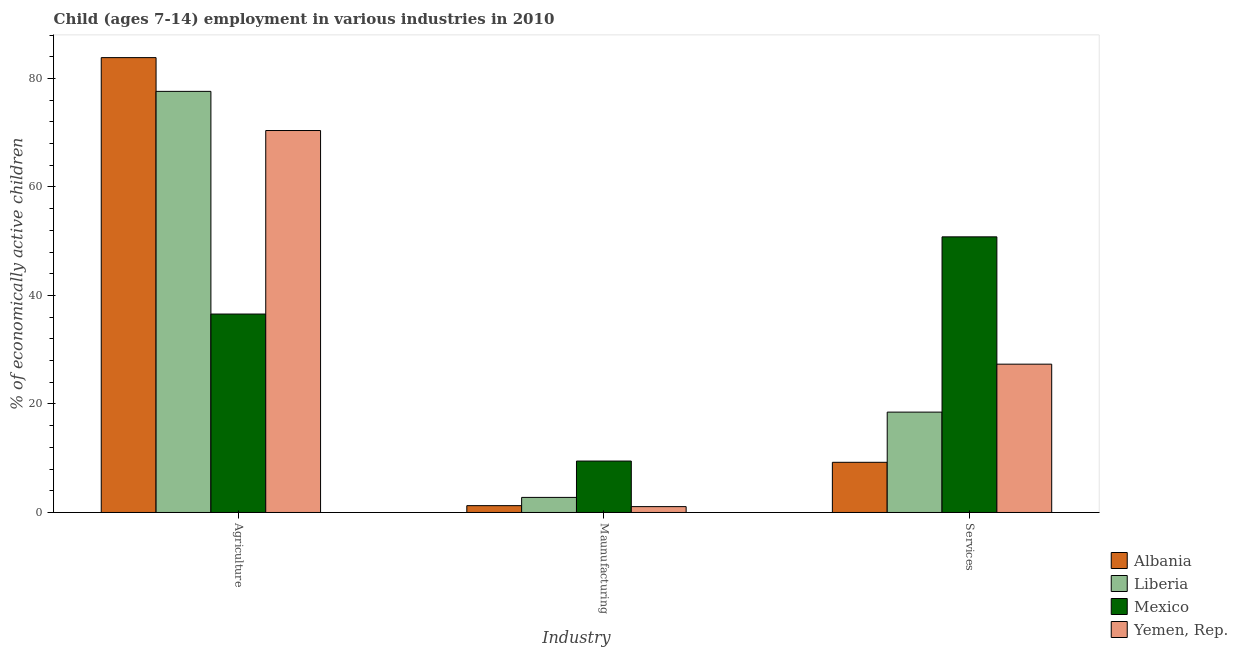How many groups of bars are there?
Provide a short and direct response. 3. How many bars are there on the 2nd tick from the left?
Give a very brief answer. 4. What is the label of the 2nd group of bars from the left?
Offer a very short reply. Maunufacturing. What is the percentage of economically active children in manufacturing in Yemen, Rep.?
Offer a terse response. 1.08. Across all countries, what is the maximum percentage of economically active children in services?
Offer a terse response. 50.81. Across all countries, what is the minimum percentage of economically active children in services?
Ensure brevity in your answer.  9.25. In which country was the percentage of economically active children in manufacturing minimum?
Provide a succinct answer. Yemen, Rep. What is the total percentage of economically active children in agriculture in the graph?
Your answer should be compact. 268.47. What is the difference between the percentage of economically active children in services in Mexico and that in Albania?
Ensure brevity in your answer.  41.56. What is the difference between the percentage of economically active children in services in Mexico and the percentage of economically active children in agriculture in Liberia?
Ensure brevity in your answer.  -26.82. What is the average percentage of economically active children in agriculture per country?
Offer a terse response. 67.12. What is the difference between the percentage of economically active children in manufacturing and percentage of economically active children in agriculture in Mexico?
Offer a terse response. -27.1. What is the ratio of the percentage of economically active children in agriculture in Liberia to that in Mexico?
Offer a terse response. 2.12. What is the difference between the highest and the second highest percentage of economically active children in manufacturing?
Keep it short and to the point. 6.7. What is the difference between the highest and the lowest percentage of economically active children in manufacturing?
Ensure brevity in your answer.  8.4. In how many countries, is the percentage of economically active children in agriculture greater than the average percentage of economically active children in agriculture taken over all countries?
Offer a very short reply. 3. What does the 2nd bar from the left in Services represents?
Your response must be concise. Liberia. What does the 3rd bar from the right in Agriculture represents?
Offer a very short reply. Liberia. Is it the case that in every country, the sum of the percentage of economically active children in agriculture and percentage of economically active children in manufacturing is greater than the percentage of economically active children in services?
Make the answer very short. No. How many countries are there in the graph?
Offer a very short reply. 4. What is the difference between two consecutive major ticks on the Y-axis?
Ensure brevity in your answer.  20. Are the values on the major ticks of Y-axis written in scientific E-notation?
Provide a succinct answer. No. How many legend labels are there?
Keep it short and to the point. 4. How are the legend labels stacked?
Ensure brevity in your answer.  Vertical. What is the title of the graph?
Provide a short and direct response. Child (ages 7-14) employment in various industries in 2010. Does "Zambia" appear as one of the legend labels in the graph?
Provide a short and direct response. No. What is the label or title of the X-axis?
Offer a terse response. Industry. What is the label or title of the Y-axis?
Offer a very short reply. % of economically active children. What is the % of economically active children in Albania in Agriculture?
Give a very brief answer. 83.85. What is the % of economically active children of Liberia in Agriculture?
Provide a succinct answer. 77.63. What is the % of economically active children in Mexico in Agriculture?
Give a very brief answer. 36.58. What is the % of economically active children of Yemen, Rep. in Agriculture?
Provide a succinct answer. 70.41. What is the % of economically active children of Albania in Maunufacturing?
Give a very brief answer. 1.26. What is the % of economically active children of Liberia in Maunufacturing?
Offer a terse response. 2.78. What is the % of economically active children of Mexico in Maunufacturing?
Give a very brief answer. 9.48. What is the % of economically active children of Albania in Services?
Your answer should be compact. 9.25. What is the % of economically active children in Mexico in Services?
Offer a very short reply. 50.81. What is the % of economically active children in Yemen, Rep. in Services?
Give a very brief answer. 27.34. Across all Industry, what is the maximum % of economically active children of Albania?
Ensure brevity in your answer.  83.85. Across all Industry, what is the maximum % of economically active children of Liberia?
Give a very brief answer. 77.63. Across all Industry, what is the maximum % of economically active children in Mexico?
Provide a succinct answer. 50.81. Across all Industry, what is the maximum % of economically active children in Yemen, Rep.?
Make the answer very short. 70.41. Across all Industry, what is the minimum % of economically active children of Albania?
Give a very brief answer. 1.26. Across all Industry, what is the minimum % of economically active children of Liberia?
Provide a short and direct response. 2.78. Across all Industry, what is the minimum % of economically active children of Mexico?
Provide a succinct answer. 9.48. What is the total % of economically active children of Albania in the graph?
Ensure brevity in your answer.  94.36. What is the total % of economically active children in Liberia in the graph?
Give a very brief answer. 98.91. What is the total % of economically active children of Mexico in the graph?
Make the answer very short. 96.87. What is the total % of economically active children of Yemen, Rep. in the graph?
Your answer should be compact. 98.83. What is the difference between the % of economically active children of Albania in Agriculture and that in Maunufacturing?
Your answer should be compact. 82.59. What is the difference between the % of economically active children of Liberia in Agriculture and that in Maunufacturing?
Offer a terse response. 74.85. What is the difference between the % of economically active children of Mexico in Agriculture and that in Maunufacturing?
Make the answer very short. 27.1. What is the difference between the % of economically active children of Yemen, Rep. in Agriculture and that in Maunufacturing?
Your answer should be very brief. 69.33. What is the difference between the % of economically active children in Albania in Agriculture and that in Services?
Your answer should be very brief. 74.6. What is the difference between the % of economically active children of Liberia in Agriculture and that in Services?
Ensure brevity in your answer.  59.13. What is the difference between the % of economically active children in Mexico in Agriculture and that in Services?
Ensure brevity in your answer.  -14.23. What is the difference between the % of economically active children in Yemen, Rep. in Agriculture and that in Services?
Offer a very short reply. 43.07. What is the difference between the % of economically active children in Albania in Maunufacturing and that in Services?
Provide a succinct answer. -7.99. What is the difference between the % of economically active children of Liberia in Maunufacturing and that in Services?
Your response must be concise. -15.72. What is the difference between the % of economically active children in Mexico in Maunufacturing and that in Services?
Provide a succinct answer. -41.33. What is the difference between the % of economically active children of Yemen, Rep. in Maunufacturing and that in Services?
Give a very brief answer. -26.26. What is the difference between the % of economically active children in Albania in Agriculture and the % of economically active children in Liberia in Maunufacturing?
Ensure brevity in your answer.  81.07. What is the difference between the % of economically active children in Albania in Agriculture and the % of economically active children in Mexico in Maunufacturing?
Offer a terse response. 74.37. What is the difference between the % of economically active children of Albania in Agriculture and the % of economically active children of Yemen, Rep. in Maunufacturing?
Keep it short and to the point. 82.77. What is the difference between the % of economically active children in Liberia in Agriculture and the % of economically active children in Mexico in Maunufacturing?
Provide a short and direct response. 68.15. What is the difference between the % of economically active children of Liberia in Agriculture and the % of economically active children of Yemen, Rep. in Maunufacturing?
Provide a short and direct response. 76.55. What is the difference between the % of economically active children in Mexico in Agriculture and the % of economically active children in Yemen, Rep. in Maunufacturing?
Provide a succinct answer. 35.5. What is the difference between the % of economically active children in Albania in Agriculture and the % of economically active children in Liberia in Services?
Offer a terse response. 65.35. What is the difference between the % of economically active children of Albania in Agriculture and the % of economically active children of Mexico in Services?
Your answer should be very brief. 33.04. What is the difference between the % of economically active children in Albania in Agriculture and the % of economically active children in Yemen, Rep. in Services?
Provide a succinct answer. 56.51. What is the difference between the % of economically active children of Liberia in Agriculture and the % of economically active children of Mexico in Services?
Make the answer very short. 26.82. What is the difference between the % of economically active children in Liberia in Agriculture and the % of economically active children in Yemen, Rep. in Services?
Your answer should be very brief. 50.29. What is the difference between the % of economically active children of Mexico in Agriculture and the % of economically active children of Yemen, Rep. in Services?
Offer a terse response. 9.24. What is the difference between the % of economically active children of Albania in Maunufacturing and the % of economically active children of Liberia in Services?
Provide a short and direct response. -17.24. What is the difference between the % of economically active children in Albania in Maunufacturing and the % of economically active children in Mexico in Services?
Offer a very short reply. -49.55. What is the difference between the % of economically active children in Albania in Maunufacturing and the % of economically active children in Yemen, Rep. in Services?
Provide a succinct answer. -26.08. What is the difference between the % of economically active children in Liberia in Maunufacturing and the % of economically active children in Mexico in Services?
Ensure brevity in your answer.  -48.03. What is the difference between the % of economically active children of Liberia in Maunufacturing and the % of economically active children of Yemen, Rep. in Services?
Offer a very short reply. -24.56. What is the difference between the % of economically active children in Mexico in Maunufacturing and the % of economically active children in Yemen, Rep. in Services?
Provide a succinct answer. -17.86. What is the average % of economically active children of Albania per Industry?
Ensure brevity in your answer.  31.45. What is the average % of economically active children in Liberia per Industry?
Ensure brevity in your answer.  32.97. What is the average % of economically active children in Mexico per Industry?
Offer a very short reply. 32.29. What is the average % of economically active children in Yemen, Rep. per Industry?
Give a very brief answer. 32.94. What is the difference between the % of economically active children in Albania and % of economically active children in Liberia in Agriculture?
Your answer should be compact. 6.22. What is the difference between the % of economically active children of Albania and % of economically active children of Mexico in Agriculture?
Provide a short and direct response. 47.27. What is the difference between the % of economically active children of Albania and % of economically active children of Yemen, Rep. in Agriculture?
Offer a terse response. 13.44. What is the difference between the % of economically active children in Liberia and % of economically active children in Mexico in Agriculture?
Provide a succinct answer. 41.05. What is the difference between the % of economically active children in Liberia and % of economically active children in Yemen, Rep. in Agriculture?
Provide a short and direct response. 7.22. What is the difference between the % of economically active children of Mexico and % of economically active children of Yemen, Rep. in Agriculture?
Provide a short and direct response. -33.83. What is the difference between the % of economically active children of Albania and % of economically active children of Liberia in Maunufacturing?
Your answer should be compact. -1.52. What is the difference between the % of economically active children in Albania and % of economically active children in Mexico in Maunufacturing?
Your answer should be very brief. -8.22. What is the difference between the % of economically active children in Albania and % of economically active children in Yemen, Rep. in Maunufacturing?
Ensure brevity in your answer.  0.18. What is the difference between the % of economically active children in Liberia and % of economically active children in Mexico in Maunufacturing?
Give a very brief answer. -6.7. What is the difference between the % of economically active children of Liberia and % of economically active children of Yemen, Rep. in Maunufacturing?
Offer a terse response. 1.7. What is the difference between the % of economically active children of Albania and % of economically active children of Liberia in Services?
Provide a short and direct response. -9.25. What is the difference between the % of economically active children of Albania and % of economically active children of Mexico in Services?
Offer a very short reply. -41.56. What is the difference between the % of economically active children of Albania and % of economically active children of Yemen, Rep. in Services?
Provide a succinct answer. -18.09. What is the difference between the % of economically active children in Liberia and % of economically active children in Mexico in Services?
Offer a terse response. -32.31. What is the difference between the % of economically active children of Liberia and % of economically active children of Yemen, Rep. in Services?
Make the answer very short. -8.84. What is the difference between the % of economically active children of Mexico and % of economically active children of Yemen, Rep. in Services?
Provide a short and direct response. 23.47. What is the ratio of the % of economically active children of Albania in Agriculture to that in Maunufacturing?
Provide a succinct answer. 66.55. What is the ratio of the % of economically active children of Liberia in Agriculture to that in Maunufacturing?
Your answer should be compact. 27.92. What is the ratio of the % of economically active children of Mexico in Agriculture to that in Maunufacturing?
Your answer should be compact. 3.86. What is the ratio of the % of economically active children of Yemen, Rep. in Agriculture to that in Maunufacturing?
Your answer should be compact. 65.19. What is the ratio of the % of economically active children of Albania in Agriculture to that in Services?
Keep it short and to the point. 9.06. What is the ratio of the % of economically active children in Liberia in Agriculture to that in Services?
Offer a very short reply. 4.2. What is the ratio of the % of economically active children of Mexico in Agriculture to that in Services?
Keep it short and to the point. 0.72. What is the ratio of the % of economically active children in Yemen, Rep. in Agriculture to that in Services?
Keep it short and to the point. 2.58. What is the ratio of the % of economically active children in Albania in Maunufacturing to that in Services?
Your answer should be very brief. 0.14. What is the ratio of the % of economically active children of Liberia in Maunufacturing to that in Services?
Make the answer very short. 0.15. What is the ratio of the % of economically active children in Mexico in Maunufacturing to that in Services?
Your response must be concise. 0.19. What is the ratio of the % of economically active children in Yemen, Rep. in Maunufacturing to that in Services?
Your answer should be very brief. 0.04. What is the difference between the highest and the second highest % of economically active children of Albania?
Make the answer very short. 74.6. What is the difference between the highest and the second highest % of economically active children of Liberia?
Provide a succinct answer. 59.13. What is the difference between the highest and the second highest % of economically active children of Mexico?
Offer a terse response. 14.23. What is the difference between the highest and the second highest % of economically active children of Yemen, Rep.?
Make the answer very short. 43.07. What is the difference between the highest and the lowest % of economically active children of Albania?
Your answer should be compact. 82.59. What is the difference between the highest and the lowest % of economically active children in Liberia?
Keep it short and to the point. 74.85. What is the difference between the highest and the lowest % of economically active children in Mexico?
Offer a terse response. 41.33. What is the difference between the highest and the lowest % of economically active children in Yemen, Rep.?
Offer a terse response. 69.33. 